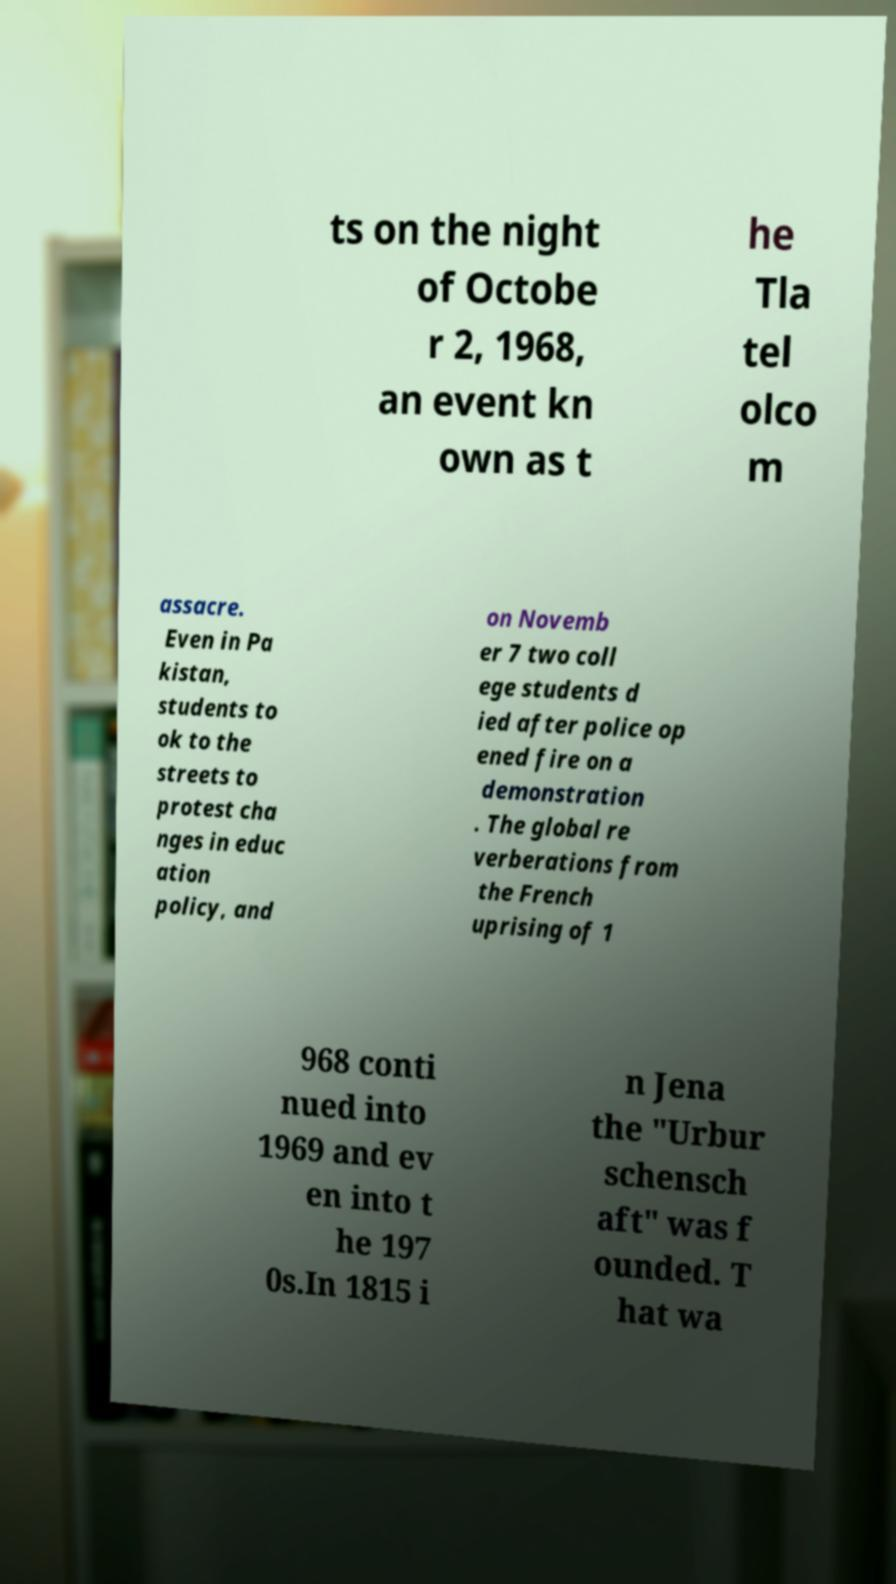There's text embedded in this image that I need extracted. Can you transcribe it verbatim? ts on the night of Octobe r 2, 1968, an event kn own as t he Tla tel olco m assacre. Even in Pa kistan, students to ok to the streets to protest cha nges in educ ation policy, and on Novemb er 7 two coll ege students d ied after police op ened fire on a demonstration . The global re verberations from the French uprising of 1 968 conti nued into 1969 and ev en into t he 197 0s.In 1815 i n Jena the "Urbur schensch aft" was f ounded. T hat wa 